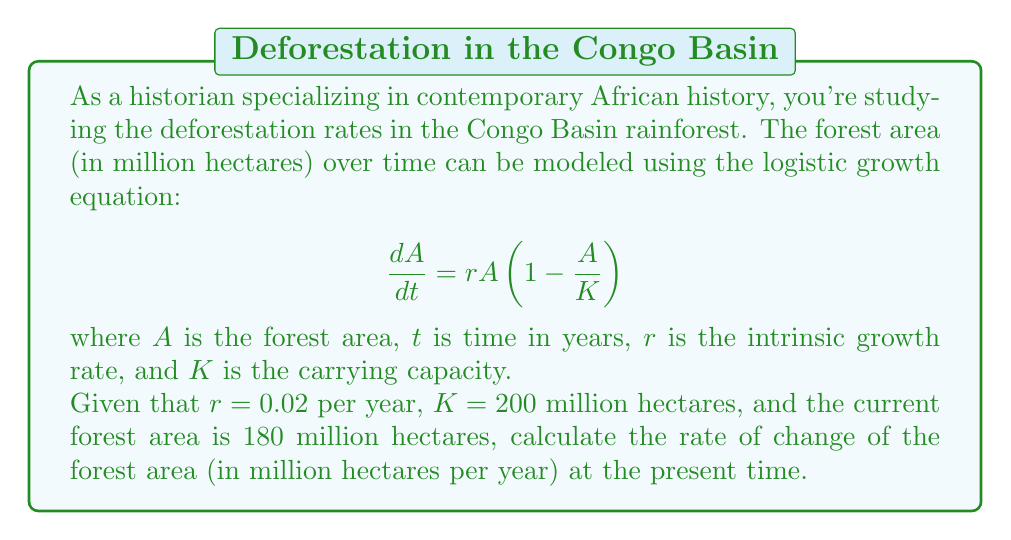Provide a solution to this math problem. To solve this problem, we'll follow these steps:

1) We are given the logistic growth equation:
   $$\frac{dA}{dt} = rA(1 - \frac{A}{K})$$

2) We know the following values:
   $r = 0.02$ per year
   $K = 200$ million hectares
   $A = 180$ million hectares (current forest area)

3) To find the rate of change, we need to substitute these values into the equation:

   $$\frac{dA}{dt} = 0.02 \cdot 180 \cdot (1 - \frac{180}{200})$$

4) Let's solve this step by step:
   
   First, calculate $\frac{180}{200} = 0.9$
   
   $$\frac{dA}{dt} = 0.02 \cdot 180 \cdot (1 - 0.9)$$
   
   $$\frac{dA}{dt} = 0.02 \cdot 180 \cdot 0.1$$
   
   $$\frac{dA}{dt} = 3.6 \cdot 0.1$$
   
   $$\frac{dA}{dt} = 0.36$$

5) Therefore, the rate of change of the forest area at the present time is 0.36 million hectares per year.

This positive value indicates that the forest area is still growing, but at a decreasing rate as it approaches the carrying capacity. However, this model doesn't account for human-induced deforestation, which would likely result in a negative rate of change in reality.
Answer: 0.36 million hectares per year 